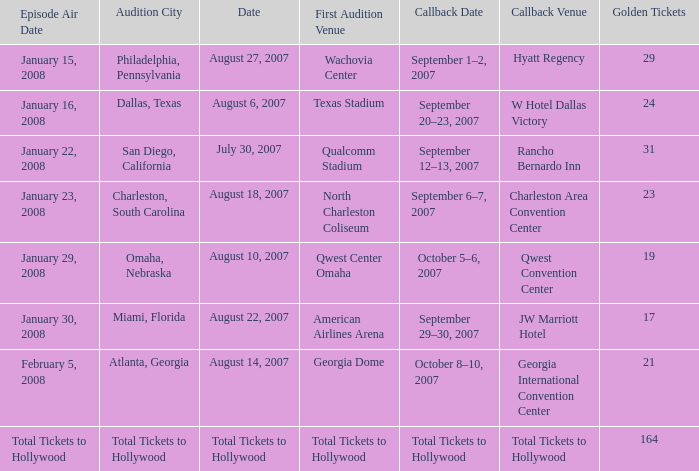How many golden tickets for the georgia international convention center? 21.0. 